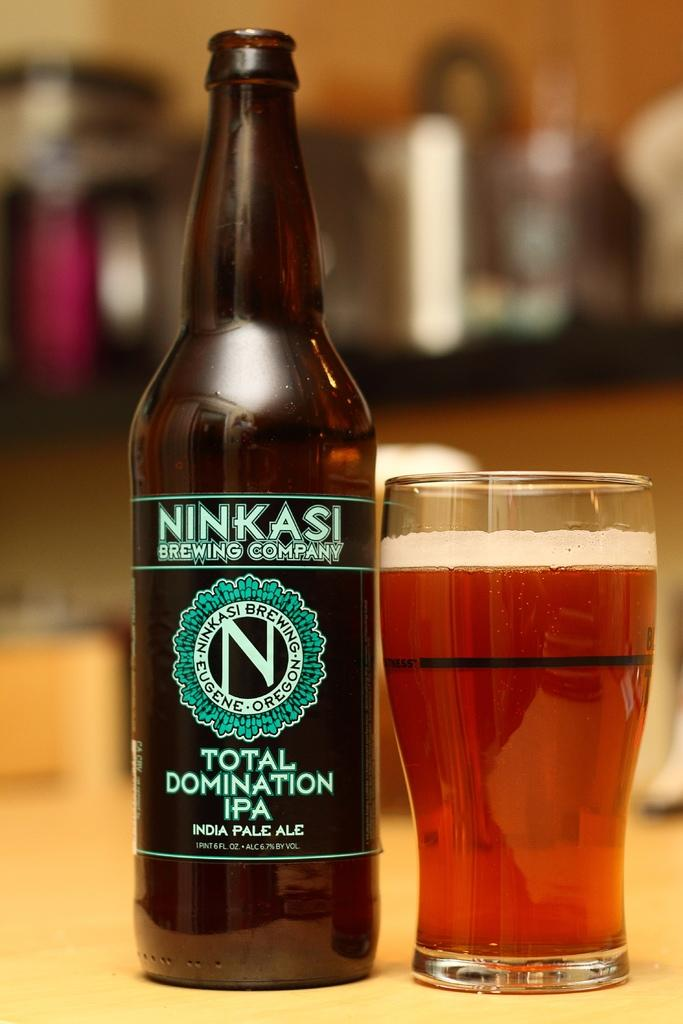<image>
Summarize the visual content of the image. A beer bottle from the Ninkasi Brewing company and a full glass of amber colored beer. 